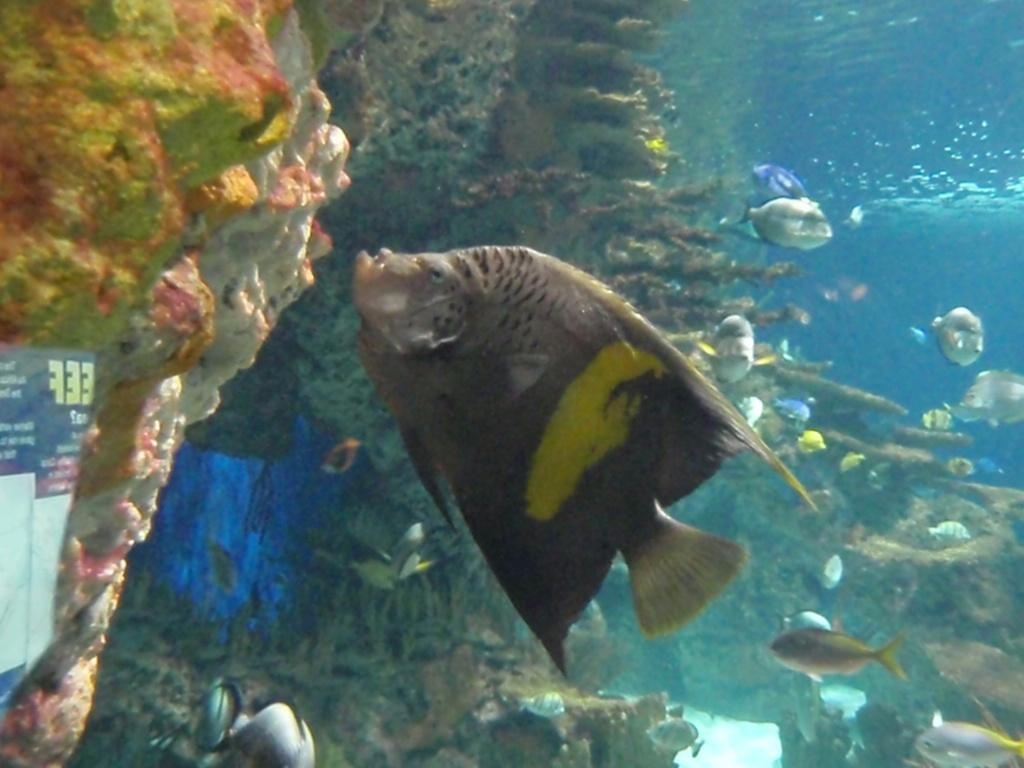What type of animals can be seen in the water in the image? There are fish in the water in the image. What is located on the left side of the image? There are boards on the left side of the image. What can be found on the boards? Something is written on the boards. What type of club can be seen in the image? There is no club present in the image. How many balls are visible in the image? There are no balls present in the image. 